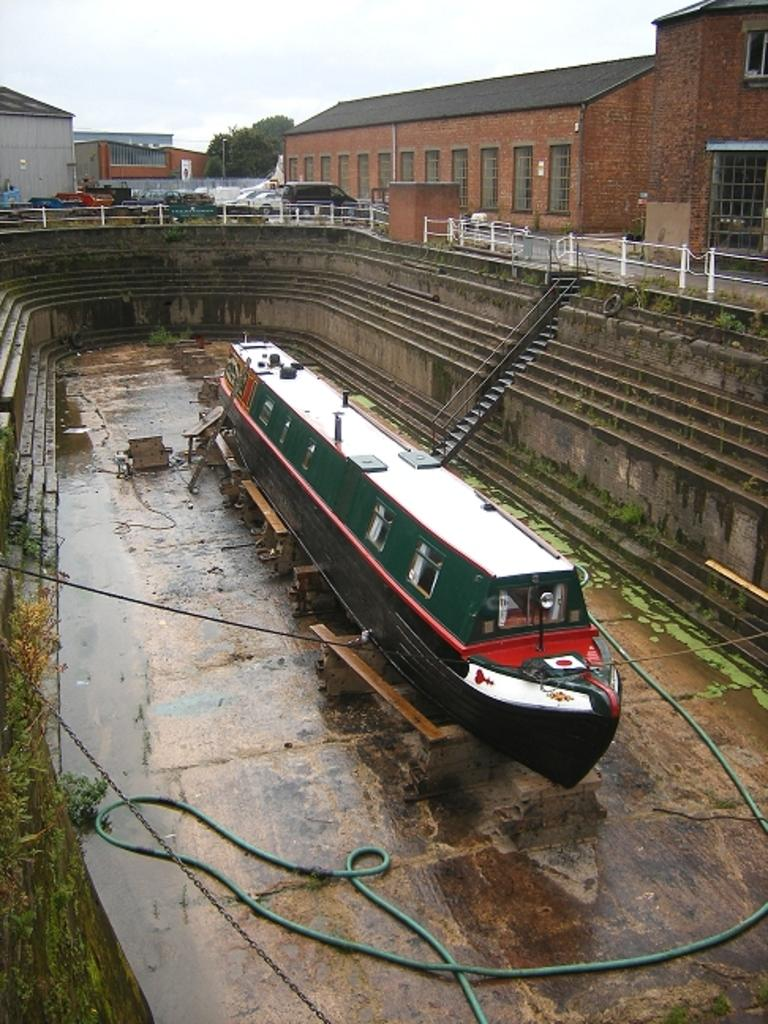What type of structures can be seen in the image? There are buildings in the image. What architectural features are present in the image? There are windows, fencing, and stairs visible in the image. What type of vegetation is present in the image? There are trees in the image. What is visible in the sky in the image? The sky is visible in the image. What type of transportation is present in the image? There are vehicles on the road in the image. What is the water-related object in the image? There is a ship in the image. What type of pipe is present in the image? There is a green pipe in the image. What type of fastener is present in the image? There is a chain in the image. How many leaves are on the tree in the image? There is no tree with leaves present in the image; the trees are not specified as having leaves. What type of dock is visible in the image? There is no dock present in the image. 